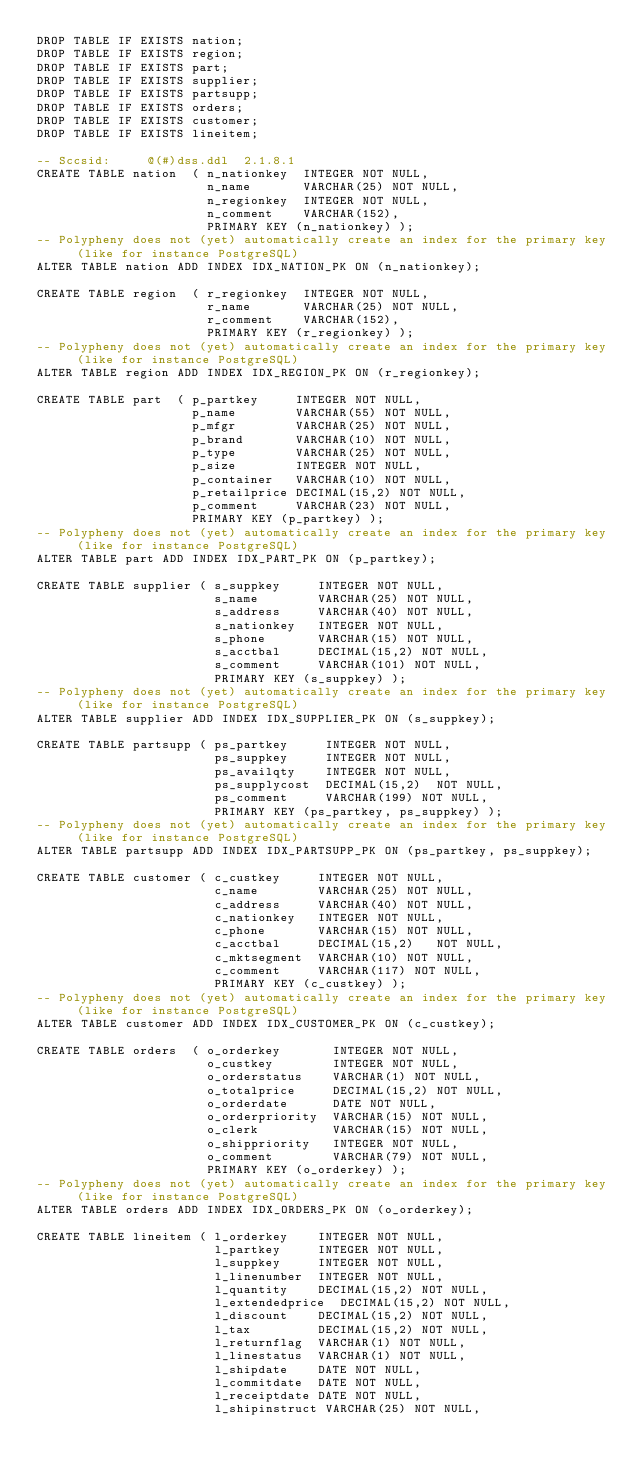<code> <loc_0><loc_0><loc_500><loc_500><_SQL_>DROP TABLE IF EXISTS nation;
DROP TABLE IF EXISTS region;
DROP TABLE IF EXISTS part;
DROP TABLE IF EXISTS supplier;
DROP TABLE IF EXISTS partsupp;
DROP TABLE IF EXISTS orders;
DROP TABLE IF EXISTS customer;
DROP TABLE IF EXISTS lineitem;

-- Sccsid:     @(#)dss.ddl  2.1.8.1
CREATE TABLE nation  ( n_nationkey  INTEGER NOT NULL,
                       n_name       VARCHAR(25) NOT NULL,
                       n_regionkey  INTEGER NOT NULL,
                       n_comment    VARCHAR(152),
                       PRIMARY KEY (n_nationkey) );
-- Polypheny does not (yet) automatically create an index for the primary key (like for instance PostgreSQL)
ALTER TABLE nation ADD INDEX IDX_NATION_PK ON (n_nationkey);

CREATE TABLE region  ( r_regionkey  INTEGER NOT NULL,
                       r_name       VARCHAR(25) NOT NULL,
                       r_comment    VARCHAR(152),
                       PRIMARY KEY (r_regionkey) );
-- Polypheny does not (yet) automatically create an index for the primary key (like for instance PostgreSQL)
ALTER TABLE region ADD INDEX IDX_REGION_PK ON (r_regionkey);

CREATE TABLE part  ( p_partkey     INTEGER NOT NULL,
                     p_name        VARCHAR(55) NOT NULL,
                     p_mfgr        VARCHAR(25) NOT NULL,
                     p_brand       VARCHAR(10) NOT NULL,
                     p_type        VARCHAR(25) NOT NULL,
                     p_size        INTEGER NOT NULL,
                     p_container   VARCHAR(10) NOT NULL,
                     p_retailprice DECIMAL(15,2) NOT NULL,
                     p_comment     VARCHAR(23) NOT NULL,
                     PRIMARY KEY (p_partkey) );
-- Polypheny does not (yet) automatically create an index for the primary key (like for instance PostgreSQL)
ALTER TABLE part ADD INDEX IDX_PART_PK ON (p_partkey);

CREATE TABLE supplier ( s_suppkey     INTEGER NOT NULL,
                        s_name        VARCHAR(25) NOT NULL,
                        s_address     VARCHAR(40) NOT NULL,
                        s_nationkey   INTEGER NOT NULL,
                        s_phone       VARCHAR(15) NOT NULL,
                        s_acctbal     DECIMAL(15,2) NOT NULL,
                        s_comment     VARCHAR(101) NOT NULL,
                        PRIMARY KEY (s_suppkey) );
-- Polypheny does not (yet) automatically create an index for the primary key (like for instance PostgreSQL)
ALTER TABLE supplier ADD INDEX IDX_SUPPLIER_PK ON (s_suppkey);

CREATE TABLE partsupp ( ps_partkey     INTEGER NOT NULL,
                        ps_suppkey     INTEGER NOT NULL,
                        ps_availqty    INTEGER NOT NULL,
                        ps_supplycost  DECIMAL(15,2)  NOT NULL,
                        ps_comment     VARCHAR(199) NOT NULL,
                        PRIMARY KEY (ps_partkey, ps_suppkey) );
-- Polypheny does not (yet) automatically create an index for the primary key (like for instance PostgreSQL)
ALTER TABLE partsupp ADD INDEX IDX_PARTSUPP_PK ON (ps_partkey, ps_suppkey);

CREATE TABLE customer ( c_custkey     INTEGER NOT NULL,
                        c_name        VARCHAR(25) NOT NULL,
                        c_address     VARCHAR(40) NOT NULL,
                        c_nationkey   INTEGER NOT NULL,
                        c_phone       VARCHAR(15) NOT NULL,
                        c_acctbal     DECIMAL(15,2)   NOT NULL,
                        c_mktsegment  VARCHAR(10) NOT NULL,
                        c_comment     VARCHAR(117) NOT NULL,
                        PRIMARY KEY (c_custkey) );
-- Polypheny does not (yet) automatically create an index for the primary key (like for instance PostgreSQL)
ALTER TABLE customer ADD INDEX IDX_CUSTOMER_PK ON (c_custkey);

CREATE TABLE orders  ( o_orderkey       INTEGER NOT NULL,
                       o_custkey        INTEGER NOT NULL,
                       o_orderstatus    VARCHAR(1) NOT NULL,
                       o_totalprice     DECIMAL(15,2) NOT NULL,
                       o_orderdate      DATE NOT NULL,
                       o_orderpriority  VARCHAR(15) NOT NULL,
                       o_clerk          VARCHAR(15) NOT NULL,
                       o_shippriority   INTEGER NOT NULL,
                       o_comment        VARCHAR(79) NOT NULL,
                       PRIMARY KEY (o_orderkey) );
-- Polypheny does not (yet) automatically create an index for the primary key (like for instance PostgreSQL)
ALTER TABLE orders ADD INDEX IDX_ORDERS_PK ON (o_orderkey);

CREATE TABLE lineitem ( l_orderkey    INTEGER NOT NULL,
                        l_partkey     INTEGER NOT NULL,
                        l_suppkey     INTEGER NOT NULL,
                        l_linenumber  INTEGER NOT NULL,
                        l_quantity    DECIMAL(15,2) NOT NULL,
                        l_extendedprice  DECIMAL(15,2) NOT NULL,
                        l_discount    DECIMAL(15,2) NOT NULL,
                        l_tax         DECIMAL(15,2) NOT NULL,
                        l_returnflag  VARCHAR(1) NOT NULL,
                        l_linestatus  VARCHAR(1) NOT NULL,
                        l_shipdate    DATE NOT NULL,
                        l_commitdate  DATE NOT NULL,
                        l_receiptdate DATE NOT NULL,
                        l_shipinstruct VARCHAR(25) NOT NULL,</code> 